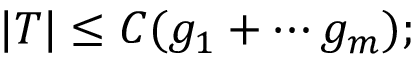<formula> <loc_0><loc_0><loc_500><loc_500>| T | \leq C ( g _ { 1 } + \cdots g _ { m } ) ;</formula> 